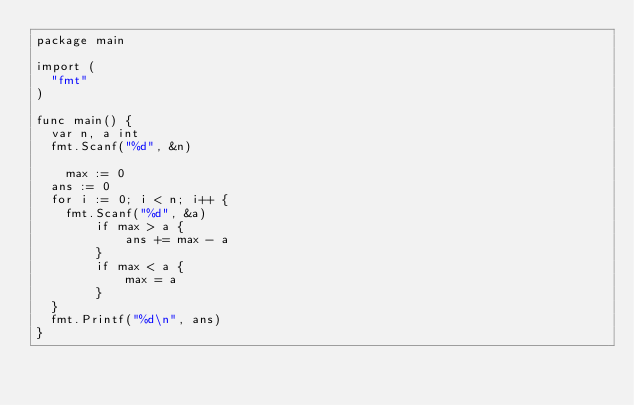Convert code to text. <code><loc_0><loc_0><loc_500><loc_500><_Go_>package main

import (
	"fmt"
)

func main() {
	var n, a int
	fmt.Scanf("%d", &n)

  	max := 0
	ans := 0
	for i := 0; i < n; i++ {
		fmt.Scanf("%d", &a)
        if max > a {
          	ans += max - a
        }
        if max < a {
          	max = a
        }
	}
	fmt.Printf("%d\n", ans)
}
</code> 